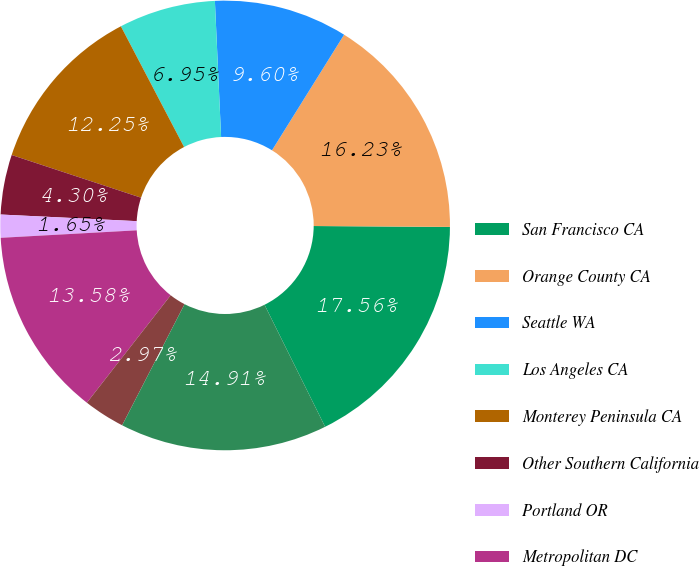Convert chart. <chart><loc_0><loc_0><loc_500><loc_500><pie_chart><fcel>San Francisco CA<fcel>Orange County CA<fcel>Seattle WA<fcel>Los Angeles CA<fcel>Monterey Peninsula CA<fcel>Other Southern California<fcel>Portland OR<fcel>Metropolitan DC<fcel>Baltimore MD<fcel>New York NY<nl><fcel>17.56%<fcel>16.23%<fcel>9.6%<fcel>6.95%<fcel>12.25%<fcel>4.3%<fcel>1.65%<fcel>13.58%<fcel>2.97%<fcel>14.91%<nl></chart> 